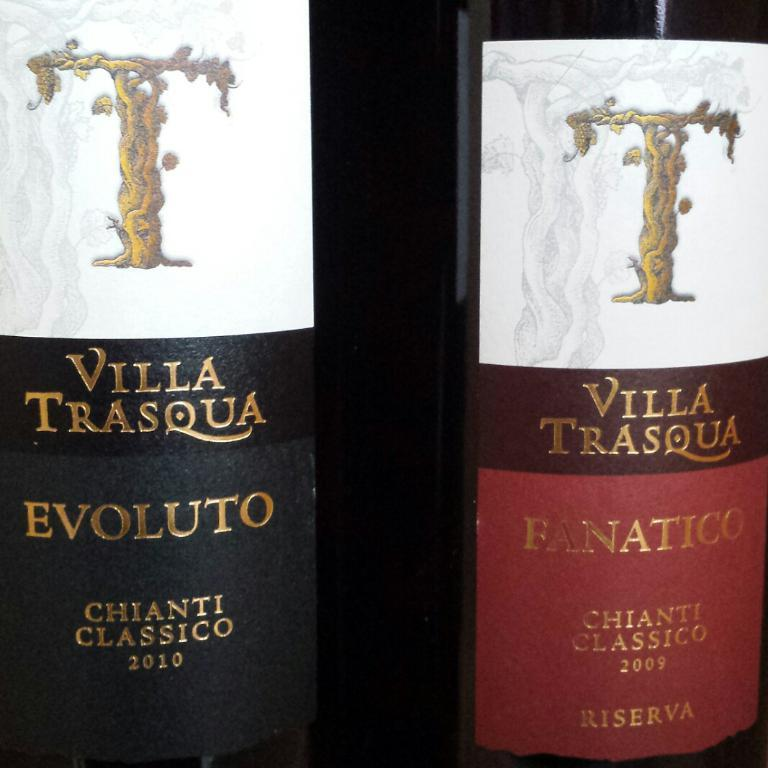<image>
Summarize the visual content of the image. A bottle has the word evoluto on it and the year 2010. 